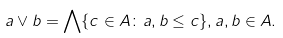<formula> <loc_0><loc_0><loc_500><loc_500>a \lor b = \bigwedge \{ c \in A \colon a , b \leq c \} , a , b \in A .</formula> 